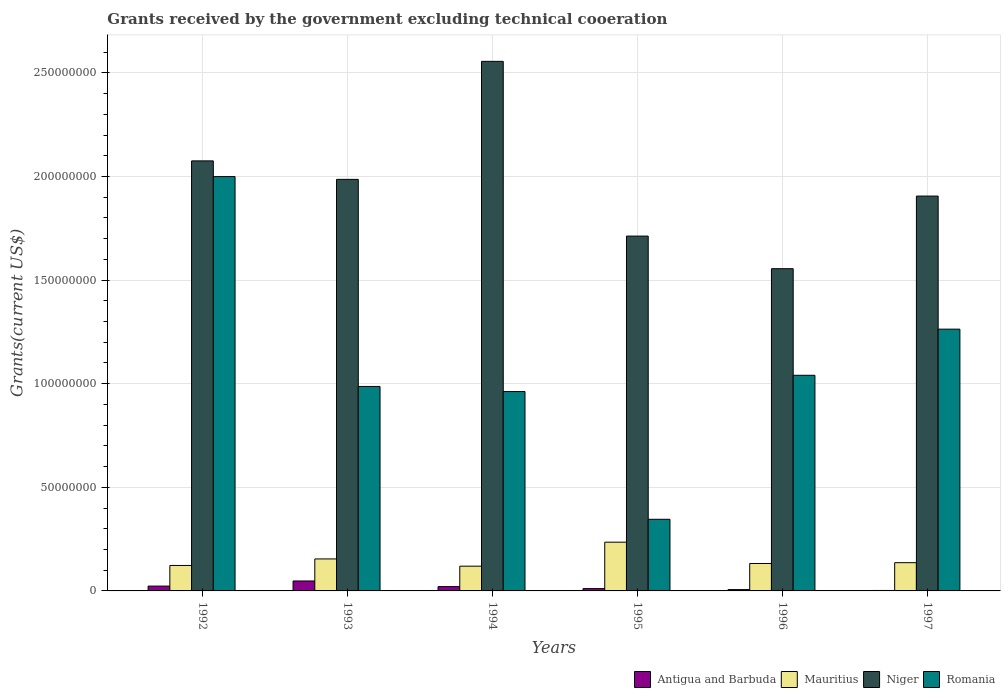How many different coloured bars are there?
Provide a succinct answer. 4. Are the number of bars per tick equal to the number of legend labels?
Your response must be concise. Yes. How many bars are there on the 4th tick from the left?
Keep it short and to the point. 4. How many bars are there on the 5th tick from the right?
Make the answer very short. 4. What is the total grants received by the government in Romania in 1997?
Give a very brief answer. 1.26e+08. Across all years, what is the maximum total grants received by the government in Romania?
Offer a terse response. 2.00e+08. Across all years, what is the minimum total grants received by the government in Romania?
Offer a very short reply. 3.46e+07. What is the total total grants received by the government in Antigua and Barbuda in the graph?
Offer a very short reply. 1.12e+07. What is the difference between the total grants received by the government in Romania in 1992 and that in 1997?
Give a very brief answer. 7.36e+07. What is the difference between the total grants received by the government in Antigua and Barbuda in 1996 and the total grants received by the government in Niger in 1994?
Provide a succinct answer. -2.55e+08. What is the average total grants received by the government in Niger per year?
Ensure brevity in your answer.  1.96e+08. In the year 1995, what is the difference between the total grants received by the government in Mauritius and total grants received by the government in Antigua and Barbuda?
Keep it short and to the point. 2.24e+07. In how many years, is the total grants received by the government in Antigua and Barbuda greater than 240000000 US$?
Offer a very short reply. 0. What is the ratio of the total grants received by the government in Mauritius in 1995 to that in 1996?
Your answer should be very brief. 1.78. Is the total grants received by the government in Antigua and Barbuda in 1995 less than that in 1996?
Your response must be concise. No. Is the difference between the total grants received by the government in Mauritius in 1993 and 1996 greater than the difference between the total grants received by the government in Antigua and Barbuda in 1993 and 1996?
Your response must be concise. No. What is the difference between the highest and the second highest total grants received by the government in Mauritius?
Offer a terse response. 8.08e+06. What is the difference between the highest and the lowest total grants received by the government in Antigua and Barbuda?
Your answer should be compact. 4.58e+06. Is the sum of the total grants received by the government in Niger in 1992 and 1997 greater than the maximum total grants received by the government in Antigua and Barbuda across all years?
Ensure brevity in your answer.  Yes. What does the 4th bar from the left in 1995 represents?
Keep it short and to the point. Romania. What does the 4th bar from the right in 1996 represents?
Offer a very short reply. Antigua and Barbuda. Is it the case that in every year, the sum of the total grants received by the government in Mauritius and total grants received by the government in Niger is greater than the total grants received by the government in Romania?
Your response must be concise. Yes. How many bars are there?
Offer a terse response. 24. Are all the bars in the graph horizontal?
Keep it short and to the point. No. How many years are there in the graph?
Keep it short and to the point. 6. What is the difference between two consecutive major ticks on the Y-axis?
Offer a very short reply. 5.00e+07. Are the values on the major ticks of Y-axis written in scientific E-notation?
Provide a short and direct response. No. Does the graph contain any zero values?
Make the answer very short. No. How many legend labels are there?
Keep it short and to the point. 4. What is the title of the graph?
Provide a short and direct response. Grants received by the government excluding technical cooeration. Does "American Samoa" appear as one of the legend labels in the graph?
Your answer should be compact. No. What is the label or title of the X-axis?
Provide a short and direct response. Years. What is the label or title of the Y-axis?
Your response must be concise. Grants(current US$). What is the Grants(current US$) of Antigua and Barbuda in 1992?
Provide a short and direct response. 2.33e+06. What is the Grants(current US$) of Mauritius in 1992?
Your answer should be compact. 1.23e+07. What is the Grants(current US$) of Niger in 1992?
Offer a terse response. 2.08e+08. What is the Grants(current US$) of Romania in 1992?
Your response must be concise. 2.00e+08. What is the Grants(current US$) of Antigua and Barbuda in 1993?
Provide a short and direct response. 4.80e+06. What is the Grants(current US$) of Mauritius in 1993?
Your answer should be very brief. 1.54e+07. What is the Grants(current US$) of Niger in 1993?
Ensure brevity in your answer.  1.99e+08. What is the Grants(current US$) in Romania in 1993?
Your response must be concise. 9.87e+07. What is the Grants(current US$) of Antigua and Barbuda in 1994?
Give a very brief answer. 2.08e+06. What is the Grants(current US$) in Mauritius in 1994?
Give a very brief answer. 1.19e+07. What is the Grants(current US$) in Niger in 1994?
Provide a short and direct response. 2.56e+08. What is the Grants(current US$) of Romania in 1994?
Offer a terse response. 9.62e+07. What is the Grants(current US$) in Antigua and Barbuda in 1995?
Offer a terse response. 1.11e+06. What is the Grants(current US$) in Mauritius in 1995?
Ensure brevity in your answer.  2.35e+07. What is the Grants(current US$) of Niger in 1995?
Ensure brevity in your answer.  1.71e+08. What is the Grants(current US$) in Romania in 1995?
Offer a very short reply. 3.46e+07. What is the Grants(current US$) of Antigua and Barbuda in 1996?
Your response must be concise. 6.40e+05. What is the Grants(current US$) of Mauritius in 1996?
Offer a terse response. 1.32e+07. What is the Grants(current US$) of Niger in 1996?
Your response must be concise. 1.56e+08. What is the Grants(current US$) in Romania in 1996?
Your response must be concise. 1.04e+08. What is the Grants(current US$) in Antigua and Barbuda in 1997?
Your response must be concise. 2.20e+05. What is the Grants(current US$) in Mauritius in 1997?
Ensure brevity in your answer.  1.36e+07. What is the Grants(current US$) in Niger in 1997?
Your answer should be compact. 1.91e+08. What is the Grants(current US$) in Romania in 1997?
Your response must be concise. 1.26e+08. Across all years, what is the maximum Grants(current US$) in Antigua and Barbuda?
Provide a succinct answer. 4.80e+06. Across all years, what is the maximum Grants(current US$) of Mauritius?
Ensure brevity in your answer.  2.35e+07. Across all years, what is the maximum Grants(current US$) of Niger?
Offer a terse response. 2.56e+08. Across all years, what is the maximum Grants(current US$) of Romania?
Give a very brief answer. 2.00e+08. Across all years, what is the minimum Grants(current US$) of Antigua and Barbuda?
Your answer should be compact. 2.20e+05. Across all years, what is the minimum Grants(current US$) in Mauritius?
Make the answer very short. 1.19e+07. Across all years, what is the minimum Grants(current US$) in Niger?
Your response must be concise. 1.56e+08. Across all years, what is the minimum Grants(current US$) in Romania?
Keep it short and to the point. 3.46e+07. What is the total Grants(current US$) of Antigua and Barbuda in the graph?
Offer a terse response. 1.12e+07. What is the total Grants(current US$) in Mauritius in the graph?
Your answer should be very brief. 9.01e+07. What is the total Grants(current US$) in Niger in the graph?
Keep it short and to the point. 1.18e+09. What is the total Grants(current US$) in Romania in the graph?
Your answer should be very brief. 6.60e+08. What is the difference between the Grants(current US$) in Antigua and Barbuda in 1992 and that in 1993?
Your answer should be very brief. -2.47e+06. What is the difference between the Grants(current US$) of Mauritius in 1992 and that in 1993?
Make the answer very short. -3.15e+06. What is the difference between the Grants(current US$) in Niger in 1992 and that in 1993?
Keep it short and to the point. 8.92e+06. What is the difference between the Grants(current US$) of Romania in 1992 and that in 1993?
Offer a terse response. 1.01e+08. What is the difference between the Grants(current US$) of Mauritius in 1992 and that in 1994?
Make the answer very short. 3.50e+05. What is the difference between the Grants(current US$) in Niger in 1992 and that in 1994?
Provide a short and direct response. -4.80e+07. What is the difference between the Grants(current US$) of Romania in 1992 and that in 1994?
Your answer should be compact. 1.04e+08. What is the difference between the Grants(current US$) of Antigua and Barbuda in 1992 and that in 1995?
Provide a succinct answer. 1.22e+06. What is the difference between the Grants(current US$) in Mauritius in 1992 and that in 1995?
Keep it short and to the point. -1.12e+07. What is the difference between the Grants(current US$) in Niger in 1992 and that in 1995?
Provide a succinct answer. 3.63e+07. What is the difference between the Grants(current US$) in Romania in 1992 and that in 1995?
Offer a terse response. 1.65e+08. What is the difference between the Grants(current US$) in Antigua and Barbuda in 1992 and that in 1996?
Offer a very short reply. 1.69e+06. What is the difference between the Grants(current US$) of Mauritius in 1992 and that in 1996?
Provide a short and direct response. -9.50e+05. What is the difference between the Grants(current US$) in Niger in 1992 and that in 1996?
Make the answer very short. 5.20e+07. What is the difference between the Grants(current US$) in Romania in 1992 and that in 1996?
Your answer should be very brief. 9.59e+07. What is the difference between the Grants(current US$) of Antigua and Barbuda in 1992 and that in 1997?
Your response must be concise. 2.11e+06. What is the difference between the Grants(current US$) in Mauritius in 1992 and that in 1997?
Offer a terse response. -1.34e+06. What is the difference between the Grants(current US$) in Niger in 1992 and that in 1997?
Keep it short and to the point. 1.70e+07. What is the difference between the Grants(current US$) of Romania in 1992 and that in 1997?
Offer a very short reply. 7.36e+07. What is the difference between the Grants(current US$) of Antigua and Barbuda in 1993 and that in 1994?
Offer a terse response. 2.72e+06. What is the difference between the Grants(current US$) in Mauritius in 1993 and that in 1994?
Give a very brief answer. 3.50e+06. What is the difference between the Grants(current US$) of Niger in 1993 and that in 1994?
Keep it short and to the point. -5.70e+07. What is the difference between the Grants(current US$) in Romania in 1993 and that in 1994?
Provide a short and direct response. 2.46e+06. What is the difference between the Grants(current US$) in Antigua and Barbuda in 1993 and that in 1995?
Offer a very short reply. 3.69e+06. What is the difference between the Grants(current US$) of Mauritius in 1993 and that in 1995?
Offer a very short reply. -8.08e+06. What is the difference between the Grants(current US$) of Niger in 1993 and that in 1995?
Your answer should be very brief. 2.74e+07. What is the difference between the Grants(current US$) of Romania in 1993 and that in 1995?
Provide a succinct answer. 6.41e+07. What is the difference between the Grants(current US$) of Antigua and Barbuda in 1993 and that in 1996?
Offer a terse response. 4.16e+06. What is the difference between the Grants(current US$) of Mauritius in 1993 and that in 1996?
Offer a very short reply. 2.20e+06. What is the difference between the Grants(current US$) of Niger in 1993 and that in 1996?
Provide a short and direct response. 4.31e+07. What is the difference between the Grants(current US$) in Romania in 1993 and that in 1996?
Provide a short and direct response. -5.39e+06. What is the difference between the Grants(current US$) of Antigua and Barbuda in 1993 and that in 1997?
Give a very brief answer. 4.58e+06. What is the difference between the Grants(current US$) of Mauritius in 1993 and that in 1997?
Provide a short and direct response. 1.81e+06. What is the difference between the Grants(current US$) in Niger in 1993 and that in 1997?
Keep it short and to the point. 8.06e+06. What is the difference between the Grants(current US$) of Romania in 1993 and that in 1997?
Your answer should be compact. -2.77e+07. What is the difference between the Grants(current US$) in Antigua and Barbuda in 1994 and that in 1995?
Offer a terse response. 9.70e+05. What is the difference between the Grants(current US$) of Mauritius in 1994 and that in 1995?
Your response must be concise. -1.16e+07. What is the difference between the Grants(current US$) in Niger in 1994 and that in 1995?
Offer a very short reply. 8.43e+07. What is the difference between the Grants(current US$) of Romania in 1994 and that in 1995?
Offer a very short reply. 6.16e+07. What is the difference between the Grants(current US$) of Antigua and Barbuda in 1994 and that in 1996?
Offer a terse response. 1.44e+06. What is the difference between the Grants(current US$) in Mauritius in 1994 and that in 1996?
Offer a very short reply. -1.30e+06. What is the difference between the Grants(current US$) in Niger in 1994 and that in 1996?
Ensure brevity in your answer.  1.00e+08. What is the difference between the Grants(current US$) in Romania in 1994 and that in 1996?
Give a very brief answer. -7.85e+06. What is the difference between the Grants(current US$) in Antigua and Barbuda in 1994 and that in 1997?
Offer a very short reply. 1.86e+06. What is the difference between the Grants(current US$) in Mauritius in 1994 and that in 1997?
Offer a terse response. -1.69e+06. What is the difference between the Grants(current US$) of Niger in 1994 and that in 1997?
Keep it short and to the point. 6.50e+07. What is the difference between the Grants(current US$) of Romania in 1994 and that in 1997?
Your answer should be very brief. -3.01e+07. What is the difference between the Grants(current US$) in Mauritius in 1995 and that in 1996?
Your response must be concise. 1.03e+07. What is the difference between the Grants(current US$) in Niger in 1995 and that in 1996?
Your response must be concise. 1.57e+07. What is the difference between the Grants(current US$) of Romania in 1995 and that in 1996?
Your answer should be compact. -6.95e+07. What is the difference between the Grants(current US$) of Antigua and Barbuda in 1995 and that in 1997?
Your response must be concise. 8.90e+05. What is the difference between the Grants(current US$) of Mauritius in 1995 and that in 1997?
Offer a very short reply. 9.89e+06. What is the difference between the Grants(current US$) of Niger in 1995 and that in 1997?
Give a very brief answer. -1.93e+07. What is the difference between the Grants(current US$) in Romania in 1995 and that in 1997?
Offer a terse response. -9.18e+07. What is the difference between the Grants(current US$) of Antigua and Barbuda in 1996 and that in 1997?
Your response must be concise. 4.20e+05. What is the difference between the Grants(current US$) in Mauritius in 1996 and that in 1997?
Ensure brevity in your answer.  -3.90e+05. What is the difference between the Grants(current US$) of Niger in 1996 and that in 1997?
Provide a succinct answer. -3.50e+07. What is the difference between the Grants(current US$) in Romania in 1996 and that in 1997?
Provide a succinct answer. -2.23e+07. What is the difference between the Grants(current US$) of Antigua and Barbuda in 1992 and the Grants(current US$) of Mauritius in 1993?
Offer a terse response. -1.31e+07. What is the difference between the Grants(current US$) of Antigua and Barbuda in 1992 and the Grants(current US$) of Niger in 1993?
Ensure brevity in your answer.  -1.96e+08. What is the difference between the Grants(current US$) of Antigua and Barbuda in 1992 and the Grants(current US$) of Romania in 1993?
Give a very brief answer. -9.63e+07. What is the difference between the Grants(current US$) in Mauritius in 1992 and the Grants(current US$) in Niger in 1993?
Your response must be concise. -1.86e+08. What is the difference between the Grants(current US$) of Mauritius in 1992 and the Grants(current US$) of Romania in 1993?
Ensure brevity in your answer.  -8.64e+07. What is the difference between the Grants(current US$) of Niger in 1992 and the Grants(current US$) of Romania in 1993?
Your answer should be very brief. 1.09e+08. What is the difference between the Grants(current US$) in Antigua and Barbuda in 1992 and the Grants(current US$) in Mauritius in 1994?
Provide a short and direct response. -9.61e+06. What is the difference between the Grants(current US$) of Antigua and Barbuda in 1992 and the Grants(current US$) of Niger in 1994?
Offer a terse response. -2.53e+08. What is the difference between the Grants(current US$) in Antigua and Barbuda in 1992 and the Grants(current US$) in Romania in 1994?
Your response must be concise. -9.39e+07. What is the difference between the Grants(current US$) of Mauritius in 1992 and the Grants(current US$) of Niger in 1994?
Make the answer very short. -2.43e+08. What is the difference between the Grants(current US$) of Mauritius in 1992 and the Grants(current US$) of Romania in 1994?
Keep it short and to the point. -8.39e+07. What is the difference between the Grants(current US$) in Niger in 1992 and the Grants(current US$) in Romania in 1994?
Make the answer very short. 1.11e+08. What is the difference between the Grants(current US$) of Antigua and Barbuda in 1992 and the Grants(current US$) of Mauritius in 1995?
Provide a short and direct response. -2.12e+07. What is the difference between the Grants(current US$) of Antigua and Barbuda in 1992 and the Grants(current US$) of Niger in 1995?
Offer a very short reply. -1.69e+08. What is the difference between the Grants(current US$) in Antigua and Barbuda in 1992 and the Grants(current US$) in Romania in 1995?
Keep it short and to the point. -3.22e+07. What is the difference between the Grants(current US$) in Mauritius in 1992 and the Grants(current US$) in Niger in 1995?
Offer a very short reply. -1.59e+08. What is the difference between the Grants(current US$) in Mauritius in 1992 and the Grants(current US$) in Romania in 1995?
Give a very brief answer. -2.23e+07. What is the difference between the Grants(current US$) in Niger in 1992 and the Grants(current US$) in Romania in 1995?
Make the answer very short. 1.73e+08. What is the difference between the Grants(current US$) of Antigua and Barbuda in 1992 and the Grants(current US$) of Mauritius in 1996?
Give a very brief answer. -1.09e+07. What is the difference between the Grants(current US$) in Antigua and Barbuda in 1992 and the Grants(current US$) in Niger in 1996?
Your answer should be compact. -1.53e+08. What is the difference between the Grants(current US$) in Antigua and Barbuda in 1992 and the Grants(current US$) in Romania in 1996?
Your answer should be compact. -1.02e+08. What is the difference between the Grants(current US$) of Mauritius in 1992 and the Grants(current US$) of Niger in 1996?
Keep it short and to the point. -1.43e+08. What is the difference between the Grants(current US$) in Mauritius in 1992 and the Grants(current US$) in Romania in 1996?
Your answer should be compact. -9.18e+07. What is the difference between the Grants(current US$) in Niger in 1992 and the Grants(current US$) in Romania in 1996?
Offer a very short reply. 1.03e+08. What is the difference between the Grants(current US$) of Antigua and Barbuda in 1992 and the Grants(current US$) of Mauritius in 1997?
Keep it short and to the point. -1.13e+07. What is the difference between the Grants(current US$) in Antigua and Barbuda in 1992 and the Grants(current US$) in Niger in 1997?
Offer a terse response. -1.88e+08. What is the difference between the Grants(current US$) of Antigua and Barbuda in 1992 and the Grants(current US$) of Romania in 1997?
Offer a very short reply. -1.24e+08. What is the difference between the Grants(current US$) of Mauritius in 1992 and the Grants(current US$) of Niger in 1997?
Provide a succinct answer. -1.78e+08. What is the difference between the Grants(current US$) in Mauritius in 1992 and the Grants(current US$) in Romania in 1997?
Provide a short and direct response. -1.14e+08. What is the difference between the Grants(current US$) of Niger in 1992 and the Grants(current US$) of Romania in 1997?
Offer a very short reply. 8.12e+07. What is the difference between the Grants(current US$) of Antigua and Barbuda in 1993 and the Grants(current US$) of Mauritius in 1994?
Ensure brevity in your answer.  -7.14e+06. What is the difference between the Grants(current US$) in Antigua and Barbuda in 1993 and the Grants(current US$) in Niger in 1994?
Provide a short and direct response. -2.51e+08. What is the difference between the Grants(current US$) of Antigua and Barbuda in 1993 and the Grants(current US$) of Romania in 1994?
Give a very brief answer. -9.14e+07. What is the difference between the Grants(current US$) of Mauritius in 1993 and the Grants(current US$) of Niger in 1994?
Make the answer very short. -2.40e+08. What is the difference between the Grants(current US$) of Mauritius in 1993 and the Grants(current US$) of Romania in 1994?
Keep it short and to the point. -8.08e+07. What is the difference between the Grants(current US$) in Niger in 1993 and the Grants(current US$) in Romania in 1994?
Your answer should be very brief. 1.02e+08. What is the difference between the Grants(current US$) of Antigua and Barbuda in 1993 and the Grants(current US$) of Mauritius in 1995?
Offer a very short reply. -1.87e+07. What is the difference between the Grants(current US$) of Antigua and Barbuda in 1993 and the Grants(current US$) of Niger in 1995?
Ensure brevity in your answer.  -1.66e+08. What is the difference between the Grants(current US$) in Antigua and Barbuda in 1993 and the Grants(current US$) in Romania in 1995?
Provide a succinct answer. -2.98e+07. What is the difference between the Grants(current US$) in Mauritius in 1993 and the Grants(current US$) in Niger in 1995?
Your answer should be very brief. -1.56e+08. What is the difference between the Grants(current US$) of Mauritius in 1993 and the Grants(current US$) of Romania in 1995?
Keep it short and to the point. -1.91e+07. What is the difference between the Grants(current US$) in Niger in 1993 and the Grants(current US$) in Romania in 1995?
Your response must be concise. 1.64e+08. What is the difference between the Grants(current US$) of Antigua and Barbuda in 1993 and the Grants(current US$) of Mauritius in 1996?
Give a very brief answer. -8.44e+06. What is the difference between the Grants(current US$) of Antigua and Barbuda in 1993 and the Grants(current US$) of Niger in 1996?
Make the answer very short. -1.51e+08. What is the difference between the Grants(current US$) of Antigua and Barbuda in 1993 and the Grants(current US$) of Romania in 1996?
Provide a short and direct response. -9.93e+07. What is the difference between the Grants(current US$) of Mauritius in 1993 and the Grants(current US$) of Niger in 1996?
Your response must be concise. -1.40e+08. What is the difference between the Grants(current US$) of Mauritius in 1993 and the Grants(current US$) of Romania in 1996?
Your answer should be compact. -8.86e+07. What is the difference between the Grants(current US$) of Niger in 1993 and the Grants(current US$) of Romania in 1996?
Make the answer very short. 9.46e+07. What is the difference between the Grants(current US$) in Antigua and Barbuda in 1993 and the Grants(current US$) in Mauritius in 1997?
Keep it short and to the point. -8.83e+06. What is the difference between the Grants(current US$) of Antigua and Barbuda in 1993 and the Grants(current US$) of Niger in 1997?
Offer a terse response. -1.86e+08. What is the difference between the Grants(current US$) in Antigua and Barbuda in 1993 and the Grants(current US$) in Romania in 1997?
Ensure brevity in your answer.  -1.22e+08. What is the difference between the Grants(current US$) of Mauritius in 1993 and the Grants(current US$) of Niger in 1997?
Make the answer very short. -1.75e+08. What is the difference between the Grants(current US$) of Mauritius in 1993 and the Grants(current US$) of Romania in 1997?
Make the answer very short. -1.11e+08. What is the difference between the Grants(current US$) of Niger in 1993 and the Grants(current US$) of Romania in 1997?
Make the answer very short. 7.23e+07. What is the difference between the Grants(current US$) in Antigua and Barbuda in 1994 and the Grants(current US$) in Mauritius in 1995?
Provide a short and direct response. -2.14e+07. What is the difference between the Grants(current US$) of Antigua and Barbuda in 1994 and the Grants(current US$) of Niger in 1995?
Provide a short and direct response. -1.69e+08. What is the difference between the Grants(current US$) in Antigua and Barbuda in 1994 and the Grants(current US$) in Romania in 1995?
Make the answer very short. -3.25e+07. What is the difference between the Grants(current US$) of Mauritius in 1994 and the Grants(current US$) of Niger in 1995?
Keep it short and to the point. -1.59e+08. What is the difference between the Grants(current US$) in Mauritius in 1994 and the Grants(current US$) in Romania in 1995?
Make the answer very short. -2.26e+07. What is the difference between the Grants(current US$) in Niger in 1994 and the Grants(current US$) in Romania in 1995?
Keep it short and to the point. 2.21e+08. What is the difference between the Grants(current US$) of Antigua and Barbuda in 1994 and the Grants(current US$) of Mauritius in 1996?
Your answer should be very brief. -1.12e+07. What is the difference between the Grants(current US$) in Antigua and Barbuda in 1994 and the Grants(current US$) in Niger in 1996?
Make the answer very short. -1.53e+08. What is the difference between the Grants(current US$) of Antigua and Barbuda in 1994 and the Grants(current US$) of Romania in 1996?
Your answer should be very brief. -1.02e+08. What is the difference between the Grants(current US$) in Mauritius in 1994 and the Grants(current US$) in Niger in 1996?
Your answer should be compact. -1.44e+08. What is the difference between the Grants(current US$) of Mauritius in 1994 and the Grants(current US$) of Romania in 1996?
Give a very brief answer. -9.21e+07. What is the difference between the Grants(current US$) in Niger in 1994 and the Grants(current US$) in Romania in 1996?
Provide a succinct answer. 1.52e+08. What is the difference between the Grants(current US$) of Antigua and Barbuda in 1994 and the Grants(current US$) of Mauritius in 1997?
Ensure brevity in your answer.  -1.16e+07. What is the difference between the Grants(current US$) in Antigua and Barbuda in 1994 and the Grants(current US$) in Niger in 1997?
Provide a succinct answer. -1.88e+08. What is the difference between the Grants(current US$) in Antigua and Barbuda in 1994 and the Grants(current US$) in Romania in 1997?
Give a very brief answer. -1.24e+08. What is the difference between the Grants(current US$) in Mauritius in 1994 and the Grants(current US$) in Niger in 1997?
Offer a very short reply. -1.79e+08. What is the difference between the Grants(current US$) in Mauritius in 1994 and the Grants(current US$) in Romania in 1997?
Give a very brief answer. -1.14e+08. What is the difference between the Grants(current US$) in Niger in 1994 and the Grants(current US$) in Romania in 1997?
Provide a succinct answer. 1.29e+08. What is the difference between the Grants(current US$) of Antigua and Barbuda in 1995 and the Grants(current US$) of Mauritius in 1996?
Provide a succinct answer. -1.21e+07. What is the difference between the Grants(current US$) in Antigua and Barbuda in 1995 and the Grants(current US$) in Niger in 1996?
Make the answer very short. -1.54e+08. What is the difference between the Grants(current US$) in Antigua and Barbuda in 1995 and the Grants(current US$) in Romania in 1996?
Ensure brevity in your answer.  -1.03e+08. What is the difference between the Grants(current US$) in Mauritius in 1995 and the Grants(current US$) in Niger in 1996?
Your answer should be compact. -1.32e+08. What is the difference between the Grants(current US$) of Mauritius in 1995 and the Grants(current US$) of Romania in 1996?
Your answer should be compact. -8.05e+07. What is the difference between the Grants(current US$) of Niger in 1995 and the Grants(current US$) of Romania in 1996?
Provide a succinct answer. 6.72e+07. What is the difference between the Grants(current US$) of Antigua and Barbuda in 1995 and the Grants(current US$) of Mauritius in 1997?
Provide a short and direct response. -1.25e+07. What is the difference between the Grants(current US$) in Antigua and Barbuda in 1995 and the Grants(current US$) in Niger in 1997?
Make the answer very short. -1.89e+08. What is the difference between the Grants(current US$) in Antigua and Barbuda in 1995 and the Grants(current US$) in Romania in 1997?
Keep it short and to the point. -1.25e+08. What is the difference between the Grants(current US$) in Mauritius in 1995 and the Grants(current US$) in Niger in 1997?
Your answer should be very brief. -1.67e+08. What is the difference between the Grants(current US$) in Mauritius in 1995 and the Grants(current US$) in Romania in 1997?
Your answer should be very brief. -1.03e+08. What is the difference between the Grants(current US$) of Niger in 1995 and the Grants(current US$) of Romania in 1997?
Ensure brevity in your answer.  4.49e+07. What is the difference between the Grants(current US$) in Antigua and Barbuda in 1996 and the Grants(current US$) in Mauritius in 1997?
Give a very brief answer. -1.30e+07. What is the difference between the Grants(current US$) in Antigua and Barbuda in 1996 and the Grants(current US$) in Niger in 1997?
Provide a short and direct response. -1.90e+08. What is the difference between the Grants(current US$) of Antigua and Barbuda in 1996 and the Grants(current US$) of Romania in 1997?
Provide a short and direct response. -1.26e+08. What is the difference between the Grants(current US$) of Mauritius in 1996 and the Grants(current US$) of Niger in 1997?
Give a very brief answer. -1.77e+08. What is the difference between the Grants(current US$) of Mauritius in 1996 and the Grants(current US$) of Romania in 1997?
Keep it short and to the point. -1.13e+08. What is the difference between the Grants(current US$) in Niger in 1996 and the Grants(current US$) in Romania in 1997?
Your response must be concise. 2.92e+07. What is the average Grants(current US$) of Antigua and Barbuda per year?
Offer a terse response. 1.86e+06. What is the average Grants(current US$) of Mauritius per year?
Provide a short and direct response. 1.50e+07. What is the average Grants(current US$) of Niger per year?
Provide a short and direct response. 1.96e+08. What is the average Grants(current US$) in Romania per year?
Keep it short and to the point. 1.10e+08. In the year 1992, what is the difference between the Grants(current US$) of Antigua and Barbuda and Grants(current US$) of Mauritius?
Provide a succinct answer. -9.96e+06. In the year 1992, what is the difference between the Grants(current US$) of Antigua and Barbuda and Grants(current US$) of Niger?
Provide a short and direct response. -2.05e+08. In the year 1992, what is the difference between the Grants(current US$) in Antigua and Barbuda and Grants(current US$) in Romania?
Offer a terse response. -1.98e+08. In the year 1992, what is the difference between the Grants(current US$) in Mauritius and Grants(current US$) in Niger?
Your response must be concise. -1.95e+08. In the year 1992, what is the difference between the Grants(current US$) of Mauritius and Grants(current US$) of Romania?
Provide a succinct answer. -1.88e+08. In the year 1992, what is the difference between the Grants(current US$) in Niger and Grants(current US$) in Romania?
Give a very brief answer. 7.57e+06. In the year 1993, what is the difference between the Grants(current US$) in Antigua and Barbuda and Grants(current US$) in Mauritius?
Provide a short and direct response. -1.06e+07. In the year 1993, what is the difference between the Grants(current US$) in Antigua and Barbuda and Grants(current US$) in Niger?
Ensure brevity in your answer.  -1.94e+08. In the year 1993, what is the difference between the Grants(current US$) of Antigua and Barbuda and Grants(current US$) of Romania?
Provide a short and direct response. -9.39e+07. In the year 1993, what is the difference between the Grants(current US$) of Mauritius and Grants(current US$) of Niger?
Your answer should be very brief. -1.83e+08. In the year 1993, what is the difference between the Grants(current US$) of Mauritius and Grants(current US$) of Romania?
Your answer should be very brief. -8.32e+07. In the year 1993, what is the difference between the Grants(current US$) of Niger and Grants(current US$) of Romania?
Your response must be concise. 9.99e+07. In the year 1994, what is the difference between the Grants(current US$) of Antigua and Barbuda and Grants(current US$) of Mauritius?
Give a very brief answer. -9.86e+06. In the year 1994, what is the difference between the Grants(current US$) in Antigua and Barbuda and Grants(current US$) in Niger?
Make the answer very short. -2.53e+08. In the year 1994, what is the difference between the Grants(current US$) in Antigua and Barbuda and Grants(current US$) in Romania?
Provide a short and direct response. -9.41e+07. In the year 1994, what is the difference between the Grants(current US$) in Mauritius and Grants(current US$) in Niger?
Offer a very short reply. -2.44e+08. In the year 1994, what is the difference between the Grants(current US$) in Mauritius and Grants(current US$) in Romania?
Your answer should be compact. -8.43e+07. In the year 1994, what is the difference between the Grants(current US$) in Niger and Grants(current US$) in Romania?
Offer a terse response. 1.59e+08. In the year 1995, what is the difference between the Grants(current US$) of Antigua and Barbuda and Grants(current US$) of Mauritius?
Offer a very short reply. -2.24e+07. In the year 1995, what is the difference between the Grants(current US$) of Antigua and Barbuda and Grants(current US$) of Niger?
Provide a short and direct response. -1.70e+08. In the year 1995, what is the difference between the Grants(current US$) of Antigua and Barbuda and Grants(current US$) of Romania?
Your response must be concise. -3.35e+07. In the year 1995, what is the difference between the Grants(current US$) of Mauritius and Grants(current US$) of Niger?
Offer a terse response. -1.48e+08. In the year 1995, what is the difference between the Grants(current US$) in Mauritius and Grants(current US$) in Romania?
Your answer should be compact. -1.10e+07. In the year 1995, what is the difference between the Grants(current US$) in Niger and Grants(current US$) in Romania?
Offer a very short reply. 1.37e+08. In the year 1996, what is the difference between the Grants(current US$) in Antigua and Barbuda and Grants(current US$) in Mauritius?
Provide a short and direct response. -1.26e+07. In the year 1996, what is the difference between the Grants(current US$) of Antigua and Barbuda and Grants(current US$) of Niger?
Make the answer very short. -1.55e+08. In the year 1996, what is the difference between the Grants(current US$) of Antigua and Barbuda and Grants(current US$) of Romania?
Your answer should be very brief. -1.03e+08. In the year 1996, what is the difference between the Grants(current US$) of Mauritius and Grants(current US$) of Niger?
Ensure brevity in your answer.  -1.42e+08. In the year 1996, what is the difference between the Grants(current US$) in Mauritius and Grants(current US$) in Romania?
Your answer should be very brief. -9.08e+07. In the year 1996, what is the difference between the Grants(current US$) in Niger and Grants(current US$) in Romania?
Give a very brief answer. 5.14e+07. In the year 1997, what is the difference between the Grants(current US$) of Antigua and Barbuda and Grants(current US$) of Mauritius?
Your response must be concise. -1.34e+07. In the year 1997, what is the difference between the Grants(current US$) in Antigua and Barbuda and Grants(current US$) in Niger?
Keep it short and to the point. -1.90e+08. In the year 1997, what is the difference between the Grants(current US$) in Antigua and Barbuda and Grants(current US$) in Romania?
Your answer should be compact. -1.26e+08. In the year 1997, what is the difference between the Grants(current US$) in Mauritius and Grants(current US$) in Niger?
Offer a very short reply. -1.77e+08. In the year 1997, what is the difference between the Grants(current US$) in Mauritius and Grants(current US$) in Romania?
Provide a short and direct response. -1.13e+08. In the year 1997, what is the difference between the Grants(current US$) in Niger and Grants(current US$) in Romania?
Your answer should be very brief. 6.42e+07. What is the ratio of the Grants(current US$) in Antigua and Barbuda in 1992 to that in 1993?
Make the answer very short. 0.49. What is the ratio of the Grants(current US$) in Mauritius in 1992 to that in 1993?
Your answer should be very brief. 0.8. What is the ratio of the Grants(current US$) in Niger in 1992 to that in 1993?
Make the answer very short. 1.04. What is the ratio of the Grants(current US$) in Romania in 1992 to that in 1993?
Provide a succinct answer. 2.03. What is the ratio of the Grants(current US$) in Antigua and Barbuda in 1992 to that in 1994?
Provide a succinct answer. 1.12. What is the ratio of the Grants(current US$) of Mauritius in 1992 to that in 1994?
Provide a short and direct response. 1.03. What is the ratio of the Grants(current US$) in Niger in 1992 to that in 1994?
Give a very brief answer. 0.81. What is the ratio of the Grants(current US$) of Romania in 1992 to that in 1994?
Your answer should be compact. 2.08. What is the ratio of the Grants(current US$) in Antigua and Barbuda in 1992 to that in 1995?
Offer a terse response. 2.1. What is the ratio of the Grants(current US$) in Mauritius in 1992 to that in 1995?
Give a very brief answer. 0.52. What is the ratio of the Grants(current US$) of Niger in 1992 to that in 1995?
Provide a succinct answer. 1.21. What is the ratio of the Grants(current US$) of Romania in 1992 to that in 1995?
Make the answer very short. 5.78. What is the ratio of the Grants(current US$) of Antigua and Barbuda in 1992 to that in 1996?
Your answer should be compact. 3.64. What is the ratio of the Grants(current US$) of Mauritius in 1992 to that in 1996?
Keep it short and to the point. 0.93. What is the ratio of the Grants(current US$) in Niger in 1992 to that in 1996?
Keep it short and to the point. 1.33. What is the ratio of the Grants(current US$) of Romania in 1992 to that in 1996?
Keep it short and to the point. 1.92. What is the ratio of the Grants(current US$) of Antigua and Barbuda in 1992 to that in 1997?
Offer a terse response. 10.59. What is the ratio of the Grants(current US$) of Mauritius in 1992 to that in 1997?
Your answer should be very brief. 0.9. What is the ratio of the Grants(current US$) in Niger in 1992 to that in 1997?
Keep it short and to the point. 1.09. What is the ratio of the Grants(current US$) in Romania in 1992 to that in 1997?
Give a very brief answer. 1.58. What is the ratio of the Grants(current US$) of Antigua and Barbuda in 1993 to that in 1994?
Give a very brief answer. 2.31. What is the ratio of the Grants(current US$) in Mauritius in 1993 to that in 1994?
Give a very brief answer. 1.29. What is the ratio of the Grants(current US$) in Niger in 1993 to that in 1994?
Provide a short and direct response. 0.78. What is the ratio of the Grants(current US$) in Romania in 1993 to that in 1994?
Your answer should be very brief. 1.03. What is the ratio of the Grants(current US$) of Antigua and Barbuda in 1993 to that in 1995?
Offer a very short reply. 4.32. What is the ratio of the Grants(current US$) in Mauritius in 1993 to that in 1995?
Keep it short and to the point. 0.66. What is the ratio of the Grants(current US$) in Niger in 1993 to that in 1995?
Make the answer very short. 1.16. What is the ratio of the Grants(current US$) of Romania in 1993 to that in 1995?
Offer a very short reply. 2.85. What is the ratio of the Grants(current US$) in Antigua and Barbuda in 1993 to that in 1996?
Provide a succinct answer. 7.5. What is the ratio of the Grants(current US$) in Mauritius in 1993 to that in 1996?
Your answer should be very brief. 1.17. What is the ratio of the Grants(current US$) in Niger in 1993 to that in 1996?
Make the answer very short. 1.28. What is the ratio of the Grants(current US$) of Romania in 1993 to that in 1996?
Your response must be concise. 0.95. What is the ratio of the Grants(current US$) in Antigua and Barbuda in 1993 to that in 1997?
Your answer should be very brief. 21.82. What is the ratio of the Grants(current US$) of Mauritius in 1993 to that in 1997?
Give a very brief answer. 1.13. What is the ratio of the Grants(current US$) in Niger in 1993 to that in 1997?
Offer a very short reply. 1.04. What is the ratio of the Grants(current US$) in Romania in 1993 to that in 1997?
Offer a very short reply. 0.78. What is the ratio of the Grants(current US$) of Antigua and Barbuda in 1994 to that in 1995?
Provide a short and direct response. 1.87. What is the ratio of the Grants(current US$) in Mauritius in 1994 to that in 1995?
Your answer should be compact. 0.51. What is the ratio of the Grants(current US$) of Niger in 1994 to that in 1995?
Ensure brevity in your answer.  1.49. What is the ratio of the Grants(current US$) in Romania in 1994 to that in 1995?
Offer a terse response. 2.78. What is the ratio of the Grants(current US$) of Mauritius in 1994 to that in 1996?
Your response must be concise. 0.9. What is the ratio of the Grants(current US$) of Niger in 1994 to that in 1996?
Keep it short and to the point. 1.64. What is the ratio of the Grants(current US$) of Romania in 1994 to that in 1996?
Offer a very short reply. 0.92. What is the ratio of the Grants(current US$) in Antigua and Barbuda in 1994 to that in 1997?
Your answer should be compact. 9.45. What is the ratio of the Grants(current US$) in Mauritius in 1994 to that in 1997?
Your answer should be very brief. 0.88. What is the ratio of the Grants(current US$) in Niger in 1994 to that in 1997?
Your answer should be compact. 1.34. What is the ratio of the Grants(current US$) of Romania in 1994 to that in 1997?
Make the answer very short. 0.76. What is the ratio of the Grants(current US$) in Antigua and Barbuda in 1995 to that in 1996?
Your answer should be very brief. 1.73. What is the ratio of the Grants(current US$) in Mauritius in 1995 to that in 1996?
Provide a succinct answer. 1.78. What is the ratio of the Grants(current US$) in Niger in 1995 to that in 1996?
Provide a short and direct response. 1.1. What is the ratio of the Grants(current US$) in Romania in 1995 to that in 1996?
Offer a terse response. 0.33. What is the ratio of the Grants(current US$) of Antigua and Barbuda in 1995 to that in 1997?
Provide a short and direct response. 5.05. What is the ratio of the Grants(current US$) in Mauritius in 1995 to that in 1997?
Your answer should be very brief. 1.73. What is the ratio of the Grants(current US$) of Niger in 1995 to that in 1997?
Your response must be concise. 0.9. What is the ratio of the Grants(current US$) in Romania in 1995 to that in 1997?
Ensure brevity in your answer.  0.27. What is the ratio of the Grants(current US$) in Antigua and Barbuda in 1996 to that in 1997?
Offer a very short reply. 2.91. What is the ratio of the Grants(current US$) in Mauritius in 1996 to that in 1997?
Your answer should be compact. 0.97. What is the ratio of the Grants(current US$) in Niger in 1996 to that in 1997?
Make the answer very short. 0.82. What is the ratio of the Grants(current US$) of Romania in 1996 to that in 1997?
Keep it short and to the point. 0.82. What is the difference between the highest and the second highest Grants(current US$) of Antigua and Barbuda?
Provide a short and direct response. 2.47e+06. What is the difference between the highest and the second highest Grants(current US$) of Mauritius?
Provide a succinct answer. 8.08e+06. What is the difference between the highest and the second highest Grants(current US$) of Niger?
Offer a terse response. 4.80e+07. What is the difference between the highest and the second highest Grants(current US$) of Romania?
Provide a succinct answer. 7.36e+07. What is the difference between the highest and the lowest Grants(current US$) in Antigua and Barbuda?
Offer a terse response. 4.58e+06. What is the difference between the highest and the lowest Grants(current US$) in Mauritius?
Your answer should be very brief. 1.16e+07. What is the difference between the highest and the lowest Grants(current US$) of Niger?
Your answer should be very brief. 1.00e+08. What is the difference between the highest and the lowest Grants(current US$) in Romania?
Offer a very short reply. 1.65e+08. 